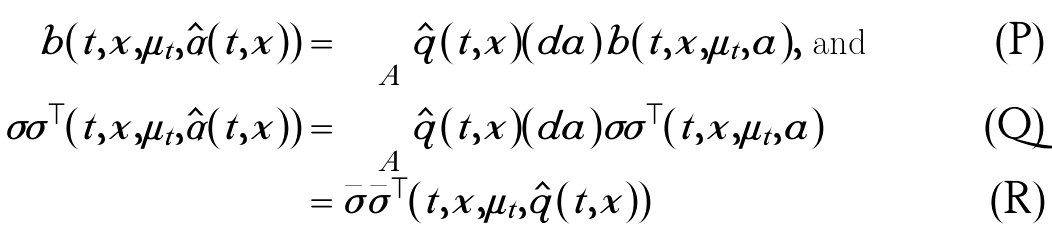<formula> <loc_0><loc_0><loc_500><loc_500>b ( t , x , \mu _ { t } , \hat { \alpha } ( t , x ) ) & = \int _ { A } \hat { q } ( t , x ) ( d a ) b ( t , x , \mu _ { t } , a ) , \text { and } \\ \sigma \sigma ^ { \top } ( t , x , \mu _ { t } , \hat { \alpha } ( t , x ) ) & = \int _ { A } \hat { q } ( t , x ) ( d a ) \sigma \sigma ^ { \top } ( t , x , \mu _ { t } , a ) \\ & = \bar { \sigma } \bar { \sigma } ^ { \top } ( t , x , \mu _ { t } , \hat { q } ( t , x ) )</formula> 